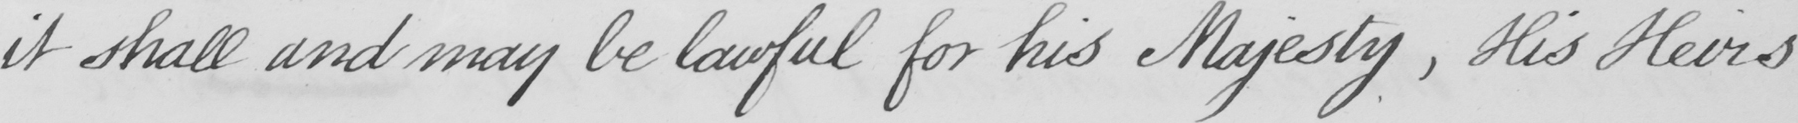What does this handwritten line say? it shall and may be lawful for his Majesty  , His Heirs 